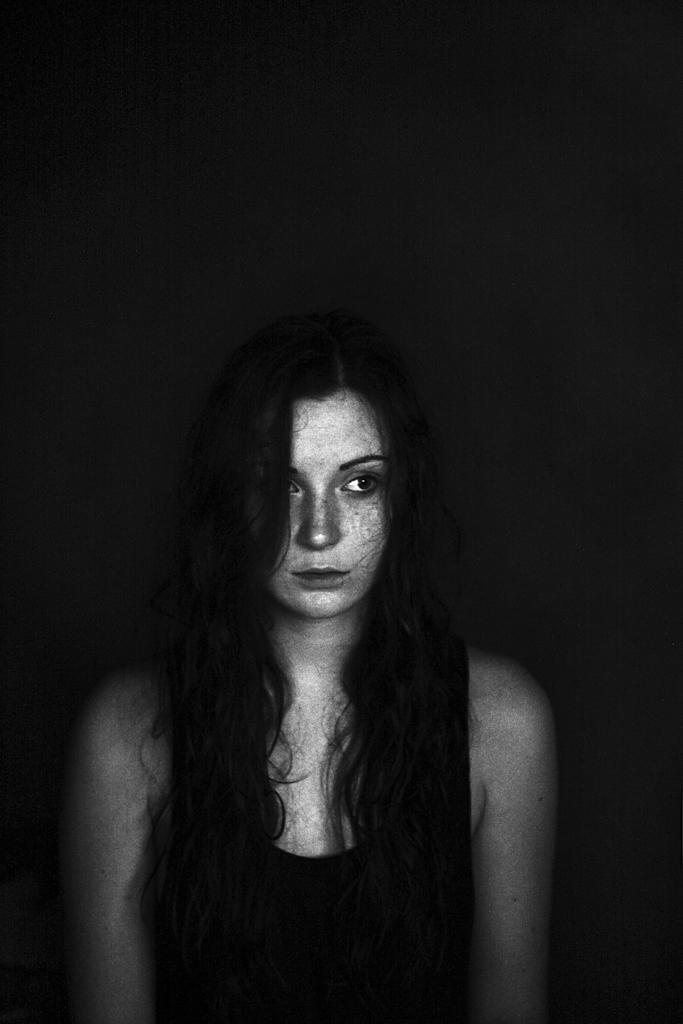What is the color scheme of the image? The image is black and white. Can you describe the person in the image? There is a woman in the image. What is the woman wearing in the image? The woman is wearing a black top. What type of fowl can be seen in the image? There is no fowl present in the image. Is the woman in the image being held in jail? There is no indication of a jail or any confinement in the image. 